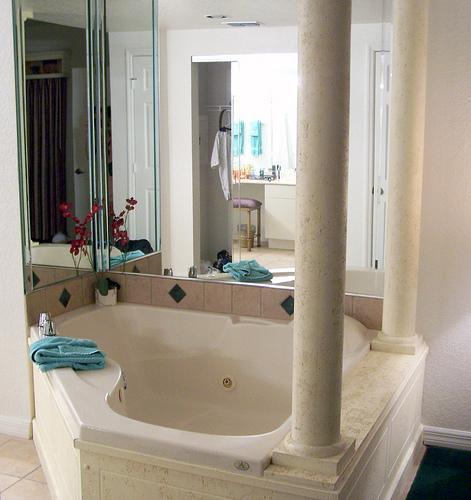How many pillars do you see?
Give a very brief answer. 2. How many tubes are in this room?
Give a very brief answer. 1. 